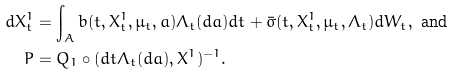Convert formula to latex. <formula><loc_0><loc_0><loc_500><loc_500>d X ^ { 1 } _ { t } & = \int _ { A } b ( t , X ^ { 1 } _ { t } , \mu _ { t } , a ) \Lambda _ { t } ( d a ) d t + \bar { \sigma } ( t , X ^ { 1 } _ { t } , \mu _ { t } , \Lambda _ { t } ) d W _ { t } , \text { and } \\ P & = Q _ { 1 } \circ ( d t \Lambda _ { t } ( d a ) , X ^ { 1 } ) ^ { - 1 } .</formula> 